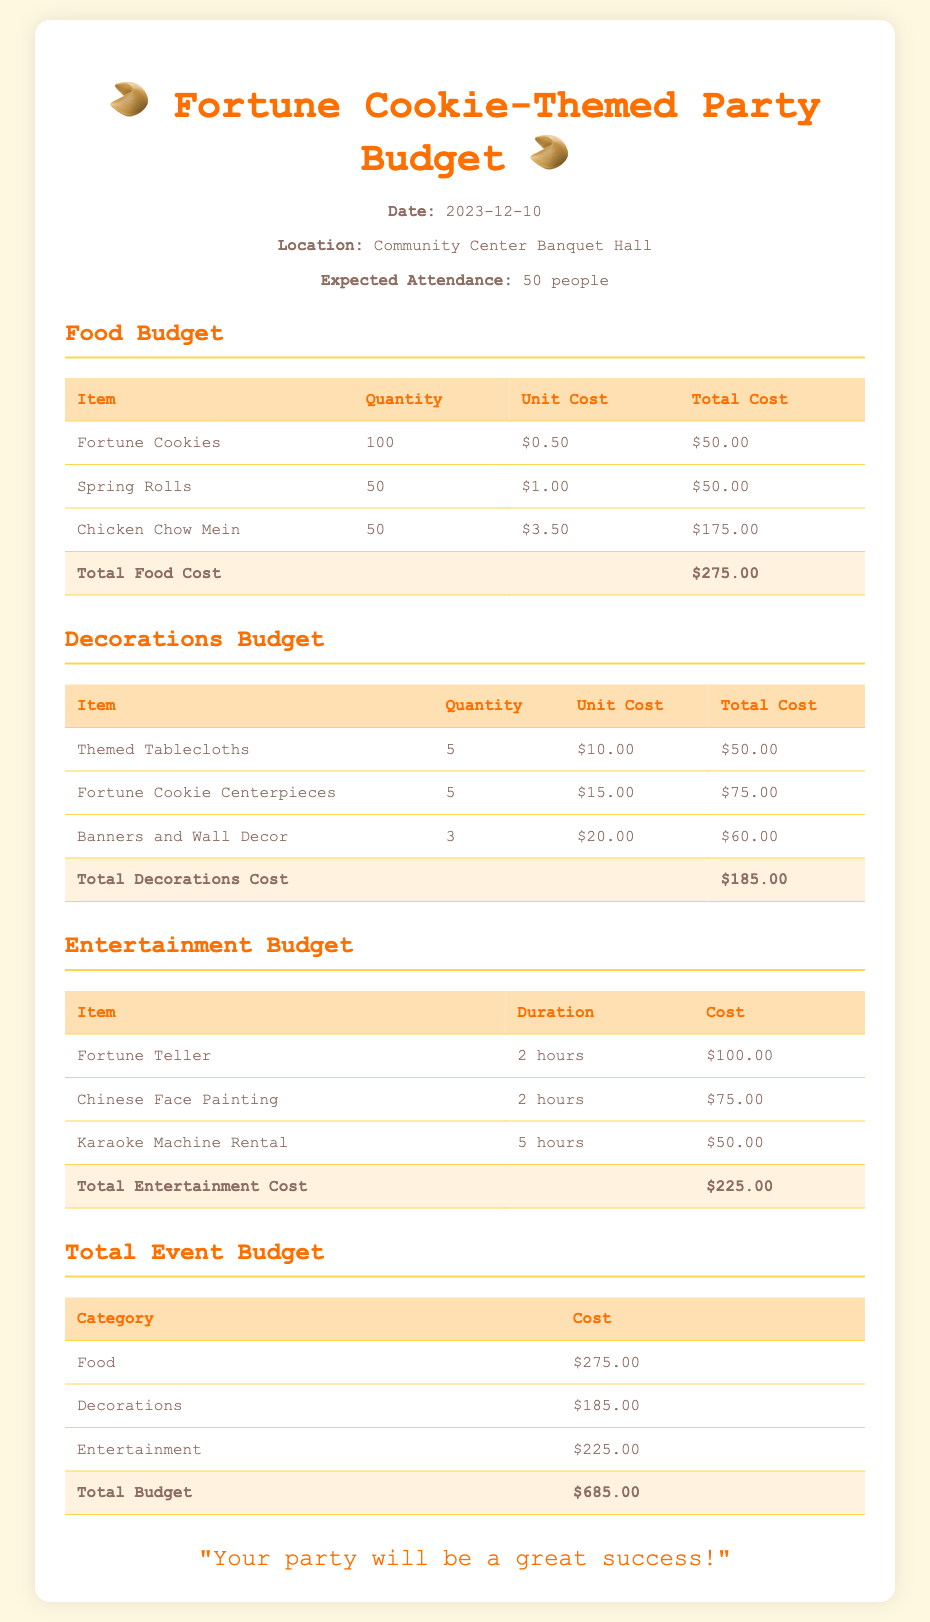What is the total food cost? The total food cost is the sum of all food items, which is $275.00.
Answer: $275.00 How many fortune cookies are planned? The quantity of fortune cookies needed for the party is clearly stated in the food budget.
Answer: 100 What is the cost of the fortune teller? The document lists the individual cost of the fortune teller under entertainment.
Answer: $100.00 What is the date of the event? The date of the party is provided in the event details section.
Answer: 2023-12-10 What is the total decorations cost? The total decorations cost is summarized at the end of the decorations budget section as $185.00.
Answer: $185.00 How many people are expected to attend? The expected attendance is mentioned in the event details section of the document.
Answer: 50 people What is the total event budget? The total event budget is the final sum of food, decorations, and entertainment costs presented in the document.
Answer: $685.00 What item has the highest unit cost in the food budget? The highest unit cost item in the food budget can be found by comparing all listed food items.
Answer: Chicken Chow Mein What is included in the entertainment section? The entertainment section lists specific activities and their associated costs, highlighting what entertainment will be provided.
Answer: Fortune Teller, Chinese Face Painting, Karaoke Machine Rental 